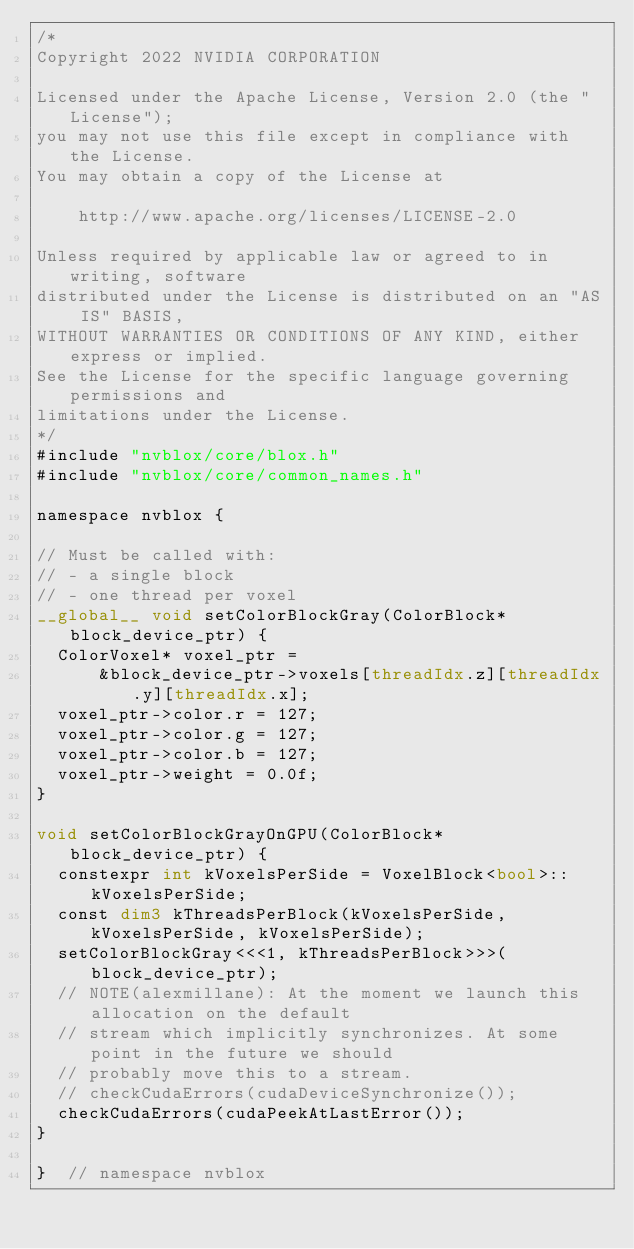Convert code to text. <code><loc_0><loc_0><loc_500><loc_500><_Cuda_>/*
Copyright 2022 NVIDIA CORPORATION

Licensed under the Apache License, Version 2.0 (the "License");
you may not use this file except in compliance with the License.
You may obtain a copy of the License at

    http://www.apache.org/licenses/LICENSE-2.0

Unless required by applicable law or agreed to in writing, software
distributed under the License is distributed on an "AS IS" BASIS,
WITHOUT WARRANTIES OR CONDITIONS OF ANY KIND, either express or implied.
See the License for the specific language governing permissions and
limitations under the License.
*/
#include "nvblox/core/blox.h"
#include "nvblox/core/common_names.h"

namespace nvblox {

// Must be called with:
// - a single block
// - one thread per voxel
__global__ void setColorBlockGray(ColorBlock* block_device_ptr) {
  ColorVoxel* voxel_ptr =
      &block_device_ptr->voxels[threadIdx.z][threadIdx.y][threadIdx.x];
  voxel_ptr->color.r = 127;
  voxel_ptr->color.g = 127;
  voxel_ptr->color.b = 127;
  voxel_ptr->weight = 0.0f;
}

void setColorBlockGrayOnGPU(ColorBlock* block_device_ptr) {
  constexpr int kVoxelsPerSide = VoxelBlock<bool>::kVoxelsPerSide;
  const dim3 kThreadsPerBlock(kVoxelsPerSide, kVoxelsPerSide, kVoxelsPerSide);
  setColorBlockGray<<<1, kThreadsPerBlock>>>(block_device_ptr);
  // NOTE(alexmillane): At the moment we launch this allocation on the default
  // stream which implicitly synchronizes. At some point in the future we should
  // probably move this to a stream.
  // checkCudaErrors(cudaDeviceSynchronize());
  checkCudaErrors(cudaPeekAtLastError());
}

}  // namespace nvblox
</code> 